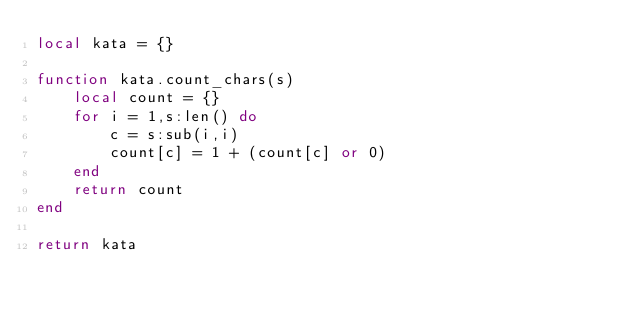<code> <loc_0><loc_0><loc_500><loc_500><_Lua_>local kata = {}

function kata.count_chars(s)
    local count = {}
    for i = 1,s:len() do
        c = s:sub(i,i)
        count[c] = 1 + (count[c] or 0)
    end
    return count
end

return kata</code> 